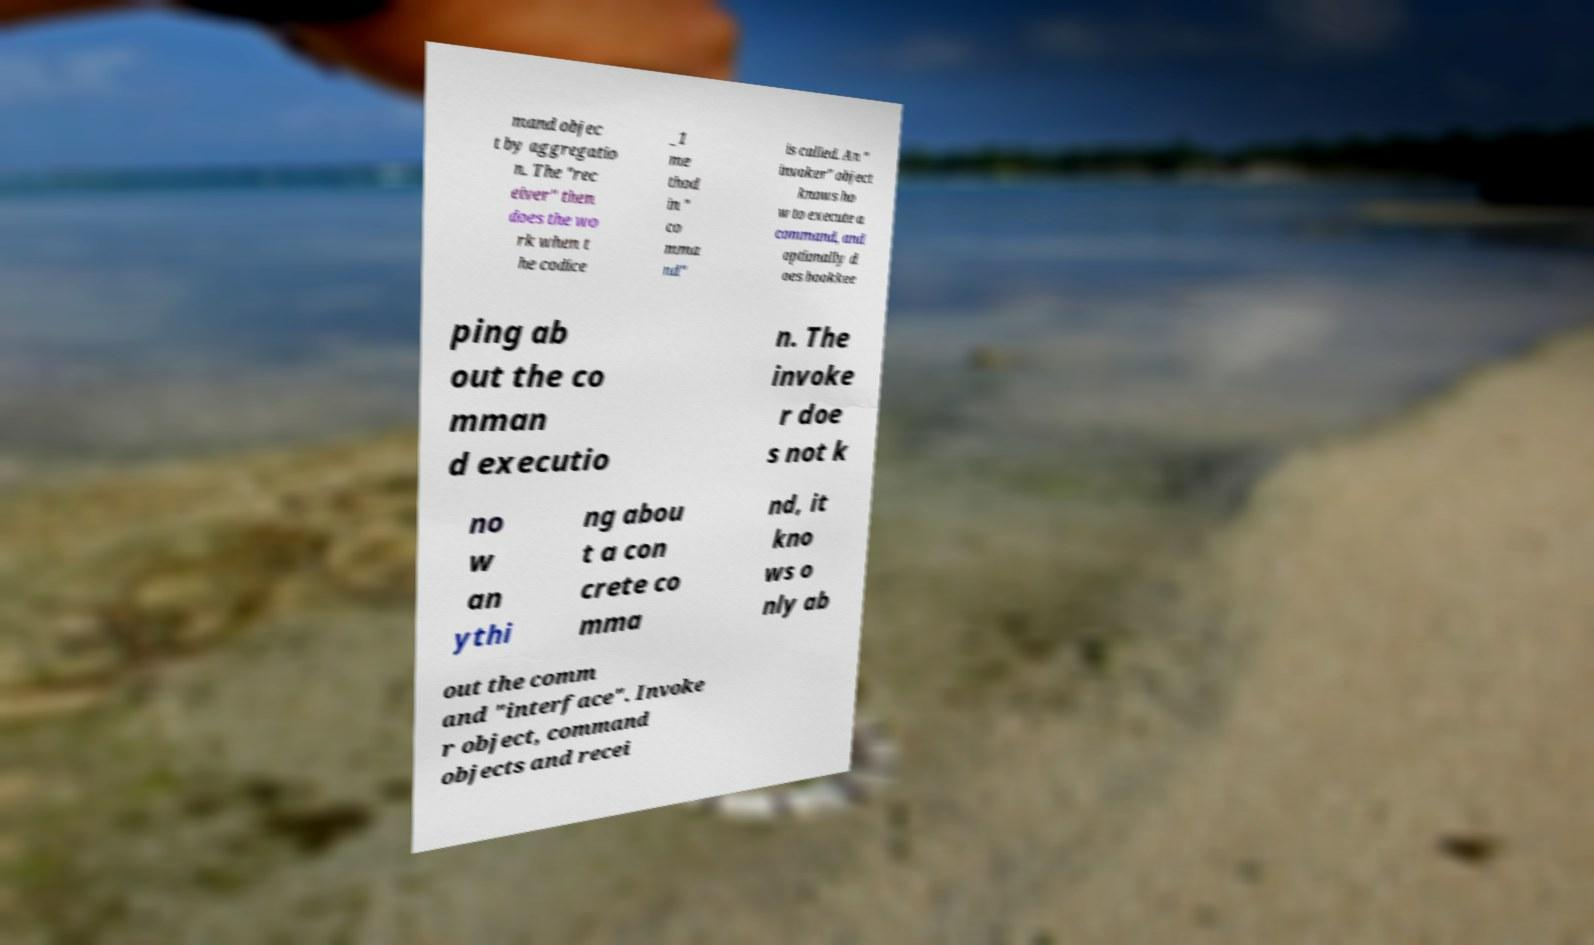Could you assist in decoding the text presented in this image and type it out clearly? mand objec t by aggregatio n. The "rec eiver" then does the wo rk when t he codice _1 me thod in " co mma nd" is called. An " invoker" object knows ho w to execute a command, and optionally d oes bookkee ping ab out the co mman d executio n. The invoke r doe s not k no w an ythi ng abou t a con crete co mma nd, it kno ws o nly ab out the comm and "interface". Invoke r object, command objects and recei 